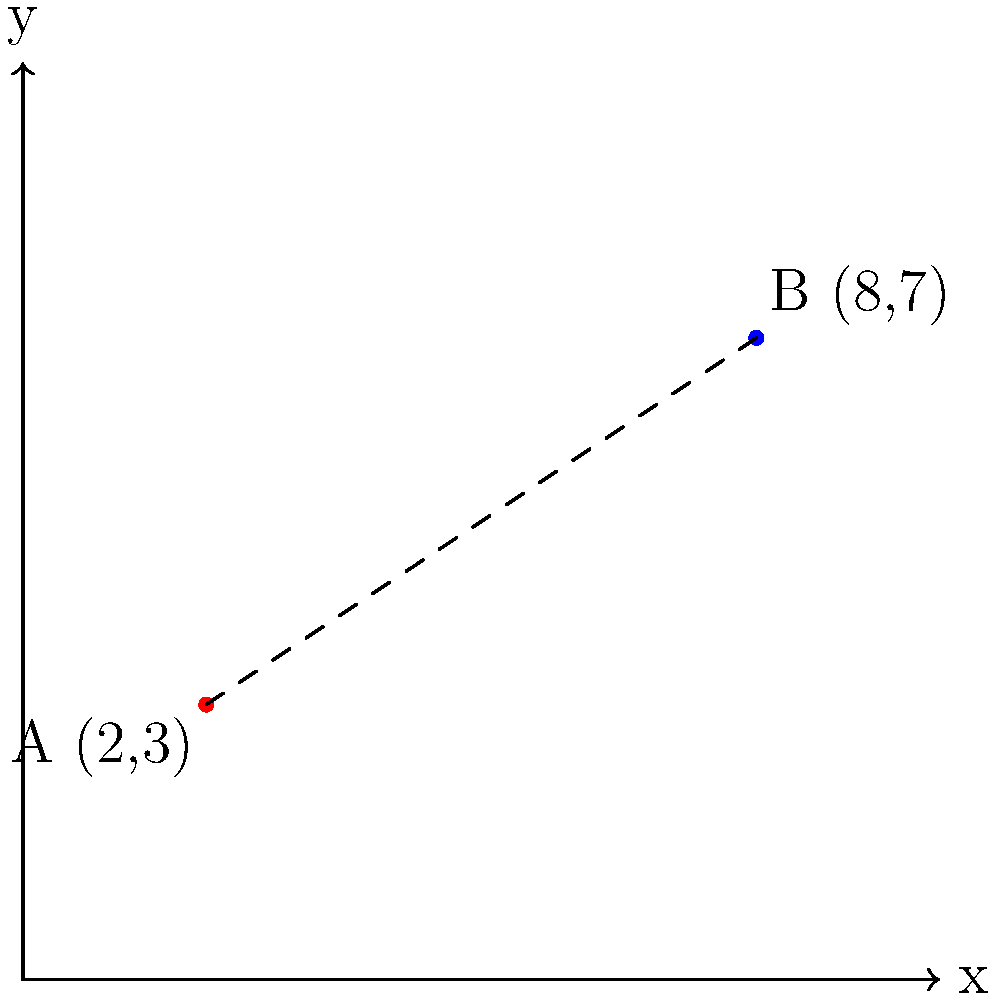As a hostel owner in Prague, you want to recommend a nearby hostel to your guests when yours is fully booked. On the city map, your hostel (A) is located at coordinates (2,3), and the other hostel (B) is at (8,7). What is the straight-line distance between these two hostels, rounded to two decimal places? To find the distance between two points on a coordinate plane, we can use the distance formula:

$$d = \sqrt{(x_2 - x_1)^2 + (y_2 - y_1)^2}$$

Where $(x_1, y_1)$ are the coordinates of the first point and $(x_2, y_2)$ are the coordinates of the second point.

Let's plug in our values:
Point A (your hostel): $(x_1, y_1) = (2, 3)$
Point B (other hostel): $(x_2, y_2) = (8, 7)$

Now, let's calculate:

1) $d = \sqrt{(8 - 2)^2 + (7 - 3)^2}$

2) $d = \sqrt{6^2 + 4^2}$

3) $d = \sqrt{36 + 16}$

4) $d = \sqrt{52}$

5) $d \approx 7.21$ (rounded to two decimal places)

Therefore, the straight-line distance between the two hostels is approximately 7.21 units on the map.
Answer: 7.21 units 